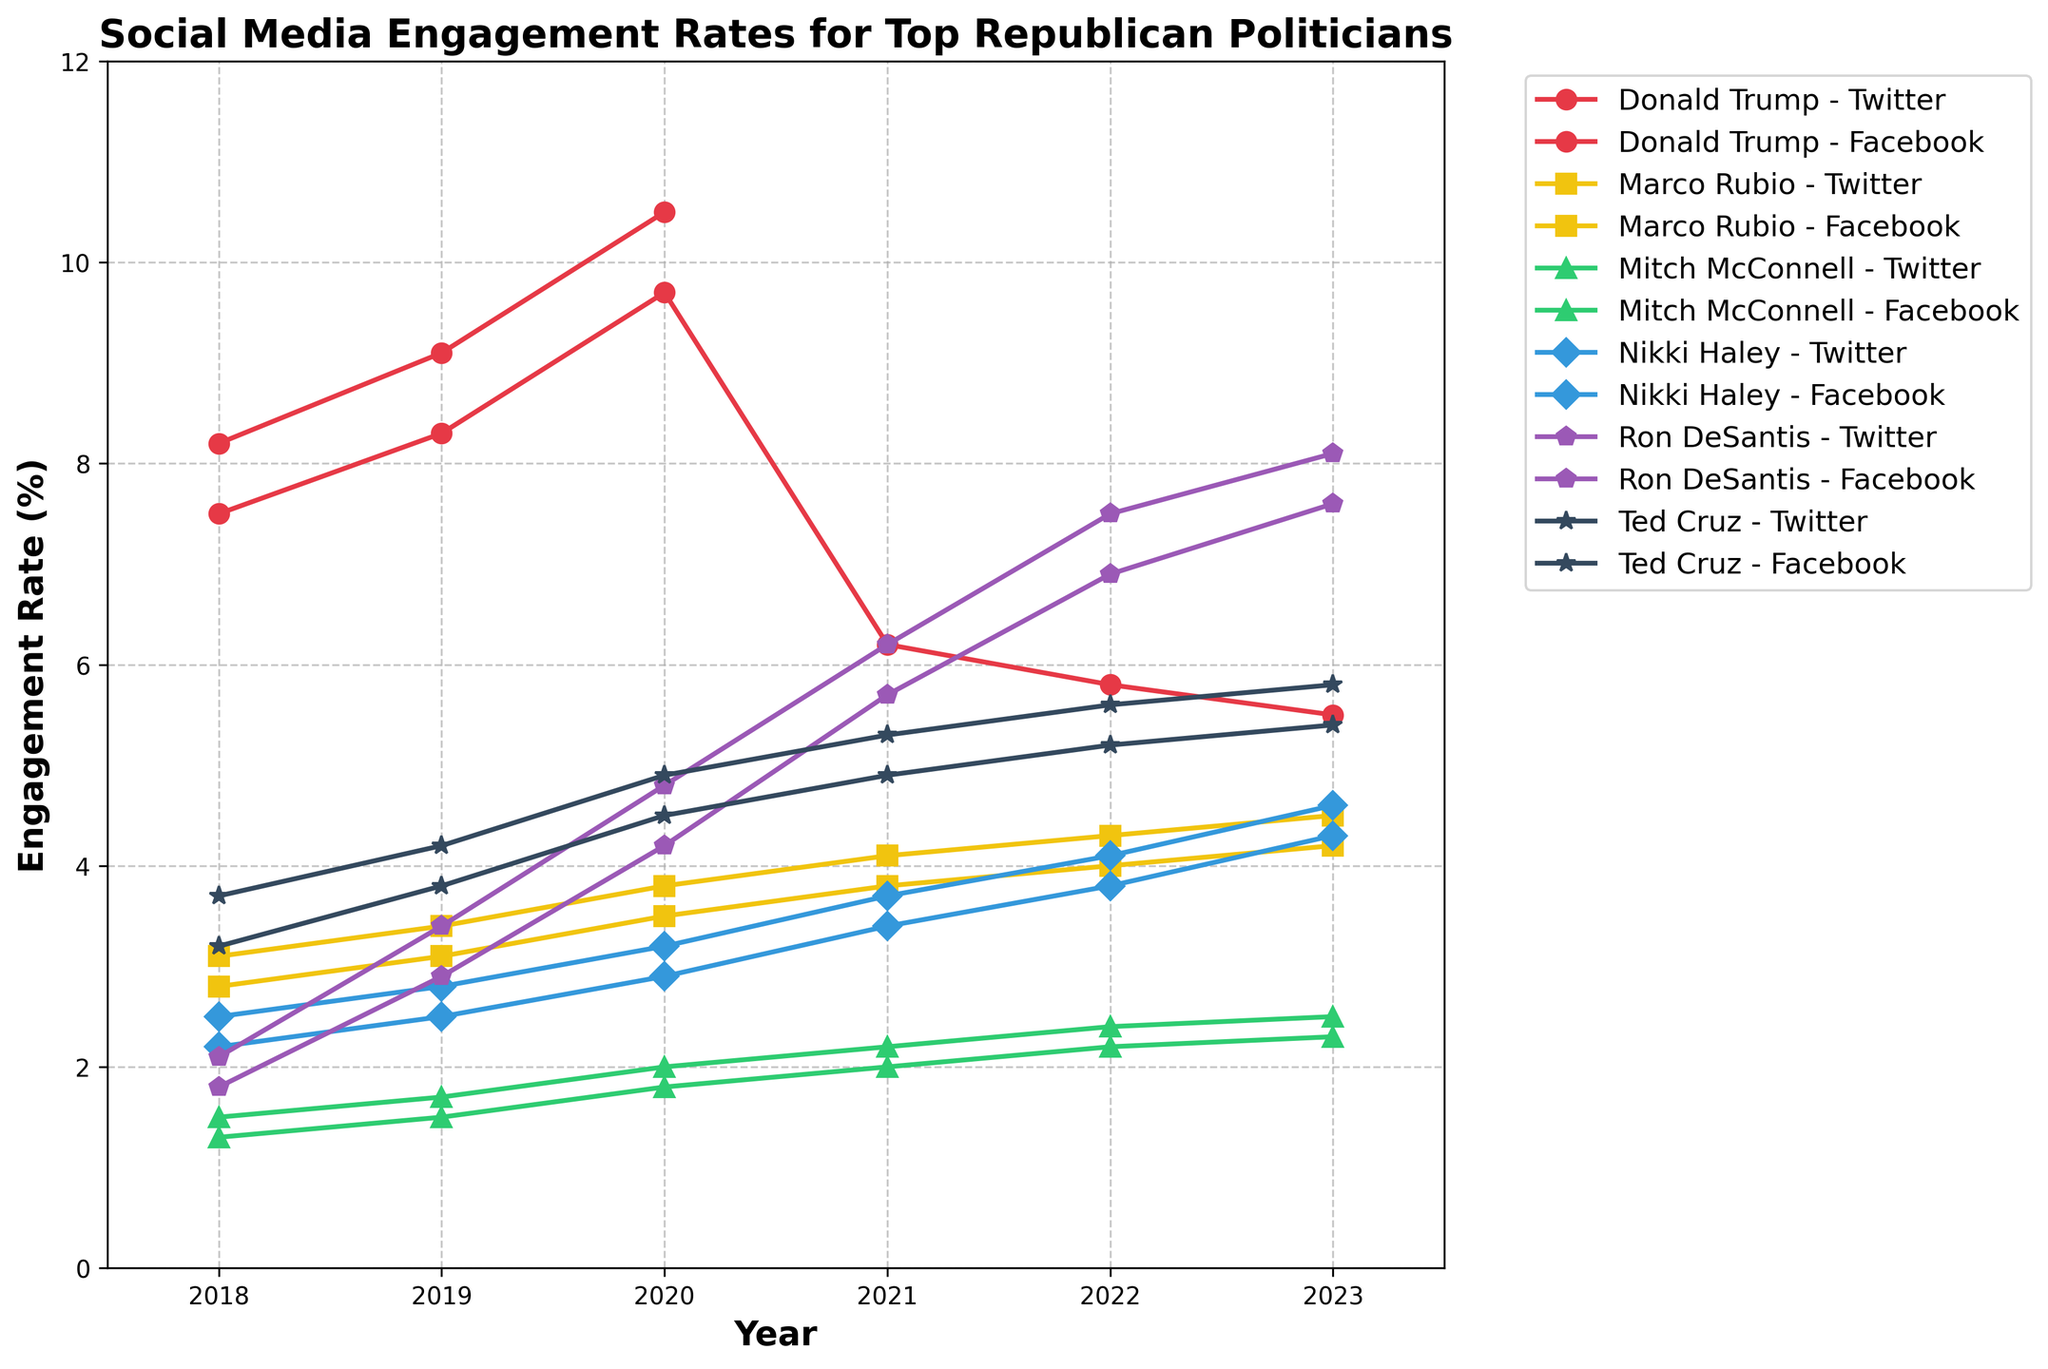What is the average engagement rate for Donald Trump on Facebook from 2018 to 2023? To find the average, sum the engagement rates for each year and divide by the number of years with data. Sum = 7.5 + 8.3 + 9.7 + 6.2 + 5.8 + 5.5 = 43. Divide by 6 since there are engagement rates for 6 years. Average = 43 / 6 = 7.17
Answer: 7.17 Which platform shows the highest engagement rate for Ron DeSantis in 2023? Look at the engagement rates for Ron DeSantis on both Twitter and Facebook in 2023. Twitter has an engagement rate of 8.1, while Facebook has 7.6. Twitter is higher.
Answer: Twitter Between 2018 and 2021, did Ted Cruz's engagement rate on Twitter ever surpass Ron DeSantis on Twitter? Compare the engagement rates for Ted Cruz and Ron DeSantis on Twitter year by year from 2018 to 2021. 2018: Ted (3.7) vs. Ron (2.1); 2019: Ted (4.2) vs. Ron (3.4); 2020: Ted (4.9) vs. Ron (4.8); 2021: Ted (5.3) vs. Ron (6.2). Ted Cruz's rates are higher from 2018 to 2020, but not in 2021.
Answer: Yes Which politician shows the most consistent increase in engagement rates on Facebook from 2018 to 2023? Review the Facebook engagement rates trend for each politician from 2018 to 2023. Look for a linear, upwards trend. Ron DeSantis shows a consistent increase from 1.8 to 7.6 each year.
Answer: Ron DeSantis Which politician has the lowest engagement rate on Twitter in 2023? Look at the Twitter engagement rates for all politicians in 2023. Mitch McConnell has the lowest rate at 2.5.
Answer: Mitch McConnell What is the difference in engagement rates on Twitter between Marco Rubio and Nikki Haley in 2021? Subtract Nikki Haley's Twitter engagement rate in 2021 from Marco Rubio's rate in the same year. Marco Rubio's rate is 4.1; Nikki Haley's rate is 3.7. Difference = 4.1 - 3.7 = 0.4
Answer: 0.4 What is the combined engagement rate for all politicians on Facebook in 2023? Sum the Facebook engagement rates for all the listed politicians in 2023. 5.5 (Trump) + 7.6 (DeSantis) + 5.4 (Cruz) + 4.3 (Haley) + 4.2 (Rubio) + 2.3 (McConnell) = 29.3
Answer: 29.3 Compare the engagement trends on Twitter from 2018 to 2021 for Donald Trump and Ron DeSantis. Who shows a more significant increase? Calculate the increase for both politicians from 2018 to 2021. Trump: N/A in 2021 vs. 8.2 in 2018 (considered as a decrease or missing data). Ron DeSantis: 6.2 in 2021 vs. 2.1 in 2018, resulting in an increase of 4.1. Ron DeSantis shows a more significant increase.
Answer: Ron DeSantis Which politician saw the biggest drop in engagement rate on Facebook between 2019 and 2020? Calculate the difference in Facebook engagement rates between 2019 and 2020 for each politician. Trump: 9.7-8.3=1.4; DeSantis: 4.2-2.9=1.3; Cruz: 4.5-3.8=0.7; Haley: 2.9-2.5=0.4; Rubio: 3.5-3.1=0.4; McConnell: 1.8-1.5=0.3. Trump has the biggest drop of 1.4.
Answer: Donald Trump 